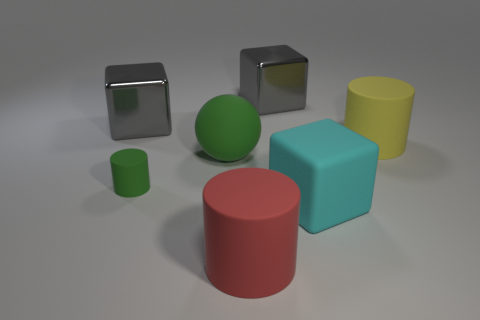Subtract all large rubber cylinders. How many cylinders are left? 1 Subtract all purple balls. How many gray blocks are left? 2 Subtract all gray blocks. How many blocks are left? 1 Subtract 1 cylinders. How many cylinders are left? 2 Add 2 large blue shiny things. How many objects exist? 9 Subtract all red cubes. Subtract all green cylinders. How many cubes are left? 3 Subtract all cylinders. How many objects are left? 4 Add 1 large gray things. How many large gray things are left? 3 Add 6 large metallic cubes. How many large metallic cubes exist? 8 Subtract 1 gray cubes. How many objects are left? 6 